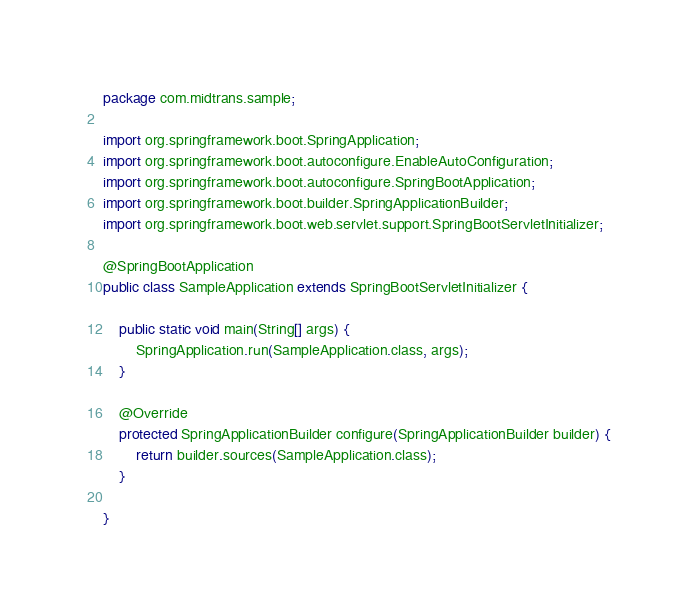Convert code to text. <code><loc_0><loc_0><loc_500><loc_500><_Java_>package com.midtrans.sample;

import org.springframework.boot.SpringApplication;
import org.springframework.boot.autoconfigure.EnableAutoConfiguration;
import org.springframework.boot.autoconfigure.SpringBootApplication;
import org.springframework.boot.builder.SpringApplicationBuilder;
import org.springframework.boot.web.servlet.support.SpringBootServletInitializer;

@SpringBootApplication
public class SampleApplication extends SpringBootServletInitializer {

    public static void main(String[] args) {
        SpringApplication.run(SampleApplication.class, args);
    }

    @Override
    protected SpringApplicationBuilder configure(SpringApplicationBuilder builder) {
        return builder.sources(SampleApplication.class);
    }

}
</code> 